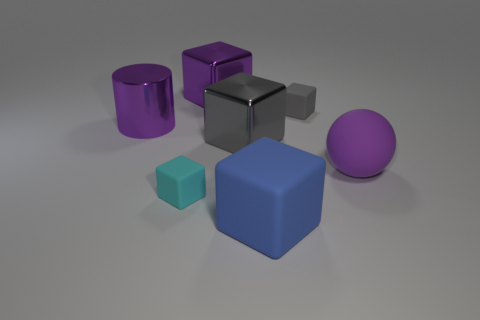Subtract all cyan blocks. How many blocks are left? 4 Subtract all brown cubes. Subtract all red cylinders. How many cubes are left? 5 Add 2 cyan matte things. How many objects exist? 9 Subtract all cylinders. How many objects are left? 6 Subtract all blue matte objects. Subtract all large metal cylinders. How many objects are left? 5 Add 2 tiny cyan blocks. How many tiny cyan blocks are left? 3 Add 6 large purple cylinders. How many large purple cylinders exist? 7 Subtract 0 yellow spheres. How many objects are left? 7 